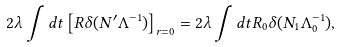<formula> <loc_0><loc_0><loc_500><loc_500>2 \lambda \int d t \left [ R \delta ( N ^ { \prime } \Lambda ^ { - 1 } ) \right ] _ { r = 0 } = 2 \lambda \int d t R _ { 0 } \delta ( N _ { 1 } \Lambda _ { 0 } ^ { - 1 } ) ,</formula> 